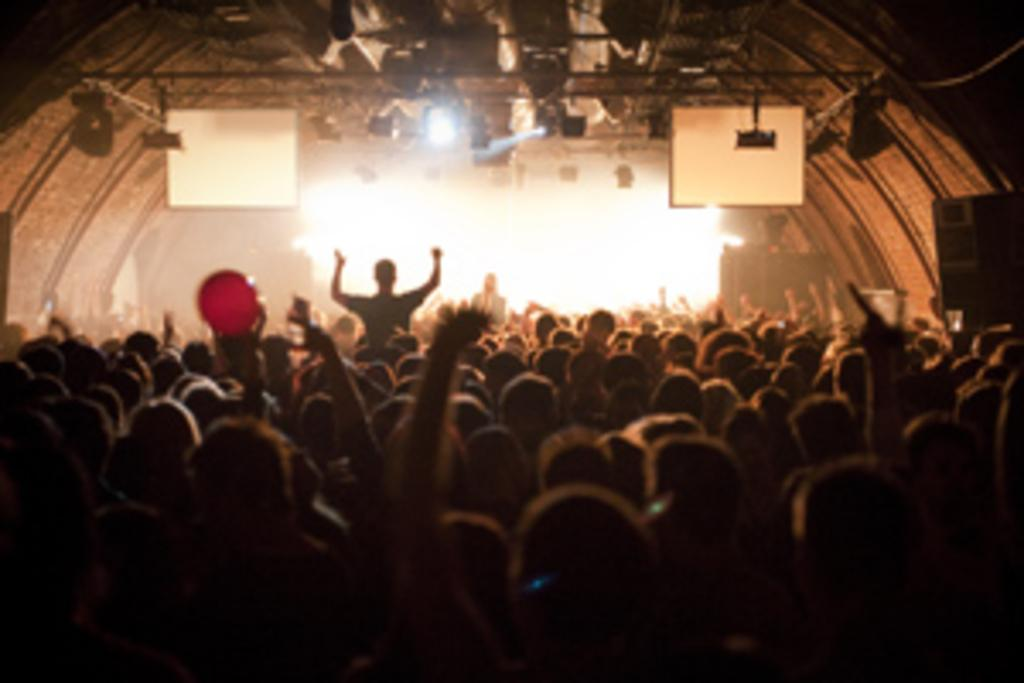How many people are in the group in the image? There is a group of people in the image, but the exact number cannot be determined from the provided facts. What is in front of the group? There is lighting and speakers in front of the group. What type of lighting is present in front of the group? There are lights in front of the group. What color objects are on both sides of the group? There are white color objects on both sides of the group. What type of government is represented by the brothers in the image? There are no brothers or any reference to a government in the image. 